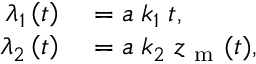<formula> <loc_0><loc_0><loc_500><loc_500>\begin{array} { r l } { \lambda _ { 1 } \left ( t \right ) } & = a \, k _ { 1 } \, t , } \\ { \lambda _ { 2 } \left ( t \right ) } & = a \, k _ { 2 } \, z _ { m } ( t ) , } \end{array}</formula> 